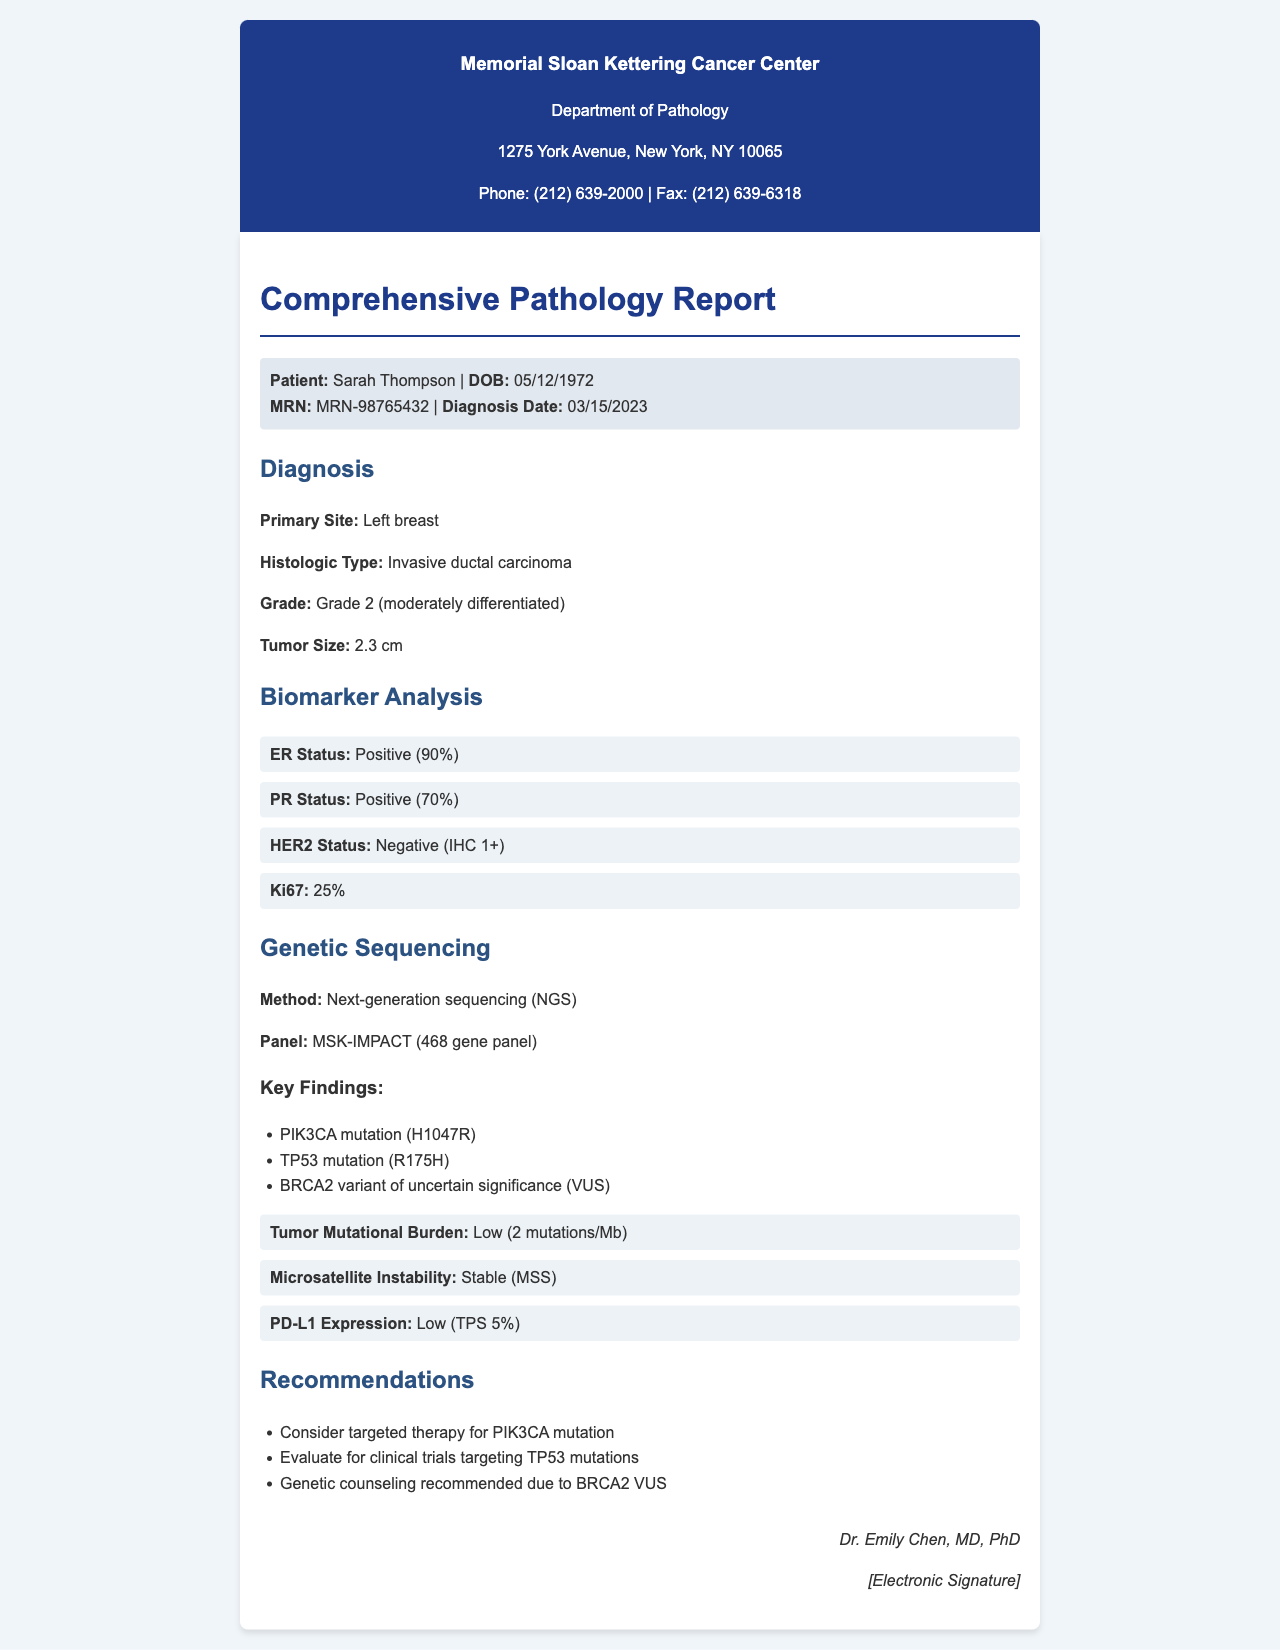What is the primary site of cancer? The primary site of cancer is explicitly mentioned in the diagnosis section of the document.
Answer: Left breast What are the ER and PR statuses? The document lists the hormone receptor statuses under biomarker analysis.
Answer: Positive (90%) and Positive (70%) What is the grade of the tumor? The tumor grade information is provided under the diagnosis section.
Answer: Grade 2 (moderately differentiated) What mutations were found in the genetic sequencing? The key findings listed in the genetic sequencing section indicate the mutations.
Answer: PIK3CA mutation (H1047R), TP53 mutation (R175H) What is the tumor mutational burden? The tumor mutational burden is specified under the genetic findings section.
Answer: Low (2 mutations/Mb) What recommendation is made regarding the PIK3CA mutation? The document provides recommendations based on genetic findings.
Answer: Consider targeted therapy for PIK3CA mutation Who signed the report? The signature section of the document includes the name of the professional who signed it.
Answer: Dr. Emily Chen, MD, PhD What is the method used for genetic sequencing? The method is stated in the genetic sequencing section of the document.
Answer: Next-generation sequencing (NGS) What is the date of diagnosis? The date of diagnosis is provided in the patient information section.
Answer: 03/15/2023 